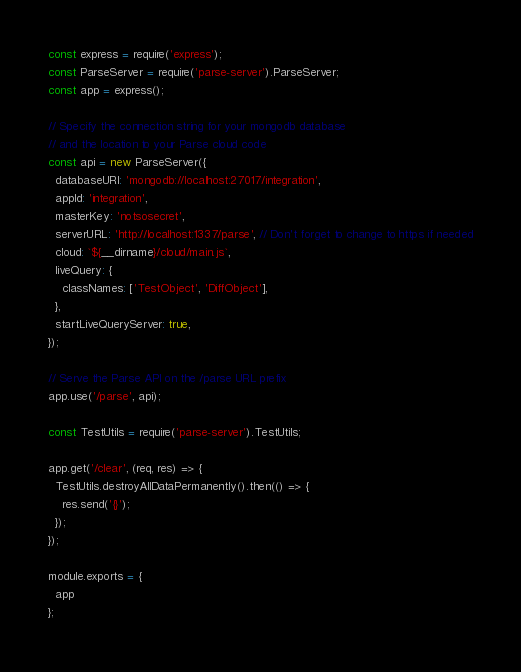<code> <loc_0><loc_0><loc_500><loc_500><_JavaScript_>const express = require('express');
const ParseServer = require('parse-server').ParseServer;
const app = express();

// Specify the connection string for your mongodb database
// and the location to your Parse cloud code
const api = new ParseServer({
  databaseURI: 'mongodb://localhost:27017/integration',
  appId: 'integration',
  masterKey: 'notsosecret',
  serverURL: 'http://localhost:1337/parse', // Don't forget to change to https if needed
  cloud: `${__dirname}/cloud/main.js`,
  liveQuery: {
    classNames: ['TestObject', 'DiffObject'],
  },
  startLiveQueryServer: true,
});

// Serve the Parse API on the /parse URL prefix
app.use('/parse', api);

const TestUtils = require('parse-server').TestUtils;

app.get('/clear', (req, res) => {
  TestUtils.destroyAllDataPermanently().then(() => {
    res.send('{}');
  });
});

module.exports = {
  app
};
</code> 